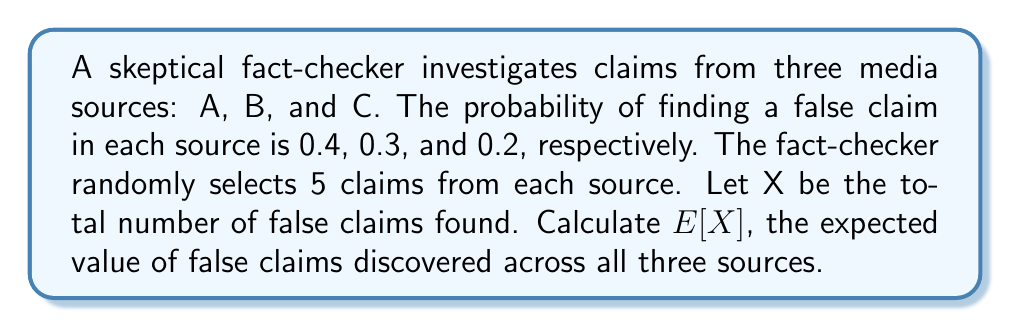Help me with this question. To solve this problem, we'll follow these steps:

1) First, let's understand what the question is asking:
   - We're checking 5 claims from each of the 3 sources
   - We need to find the expected number of false claims in total

2) For each source, the number of false claims follows a binomial distribution:
   - Source A: $X_A \sim B(5, 0.4)$
   - Source B: $X_B \sim B(5, 0.3)$
   - Source C: $X_C \sim B(5, 0.2)$

3) The expected value of a binomial distribution is $np$, where $n$ is the number of trials and $p$ is the probability of success (in this case, finding a false claim).

4) Calculate the expected value for each source:
   - $E[X_A] = 5 \times 0.4 = 2$
   - $E[X_B] = 5 \times 0.3 = 1.5$
   - $E[X_C] = 5 \times 0.2 = 1$

5) The total number of false claims $X = X_A + X_B + X_C$

6) By the linearity of expectation:
   $E[X] = E[X_A] + E[X_B] + E[X_C]$

7) Substituting the values:
   $E[X] = 2 + 1.5 + 1 = 4.5$

Therefore, the expected number of false claims across all three sources is 4.5.
Answer: $E[X] = 4.5$ 